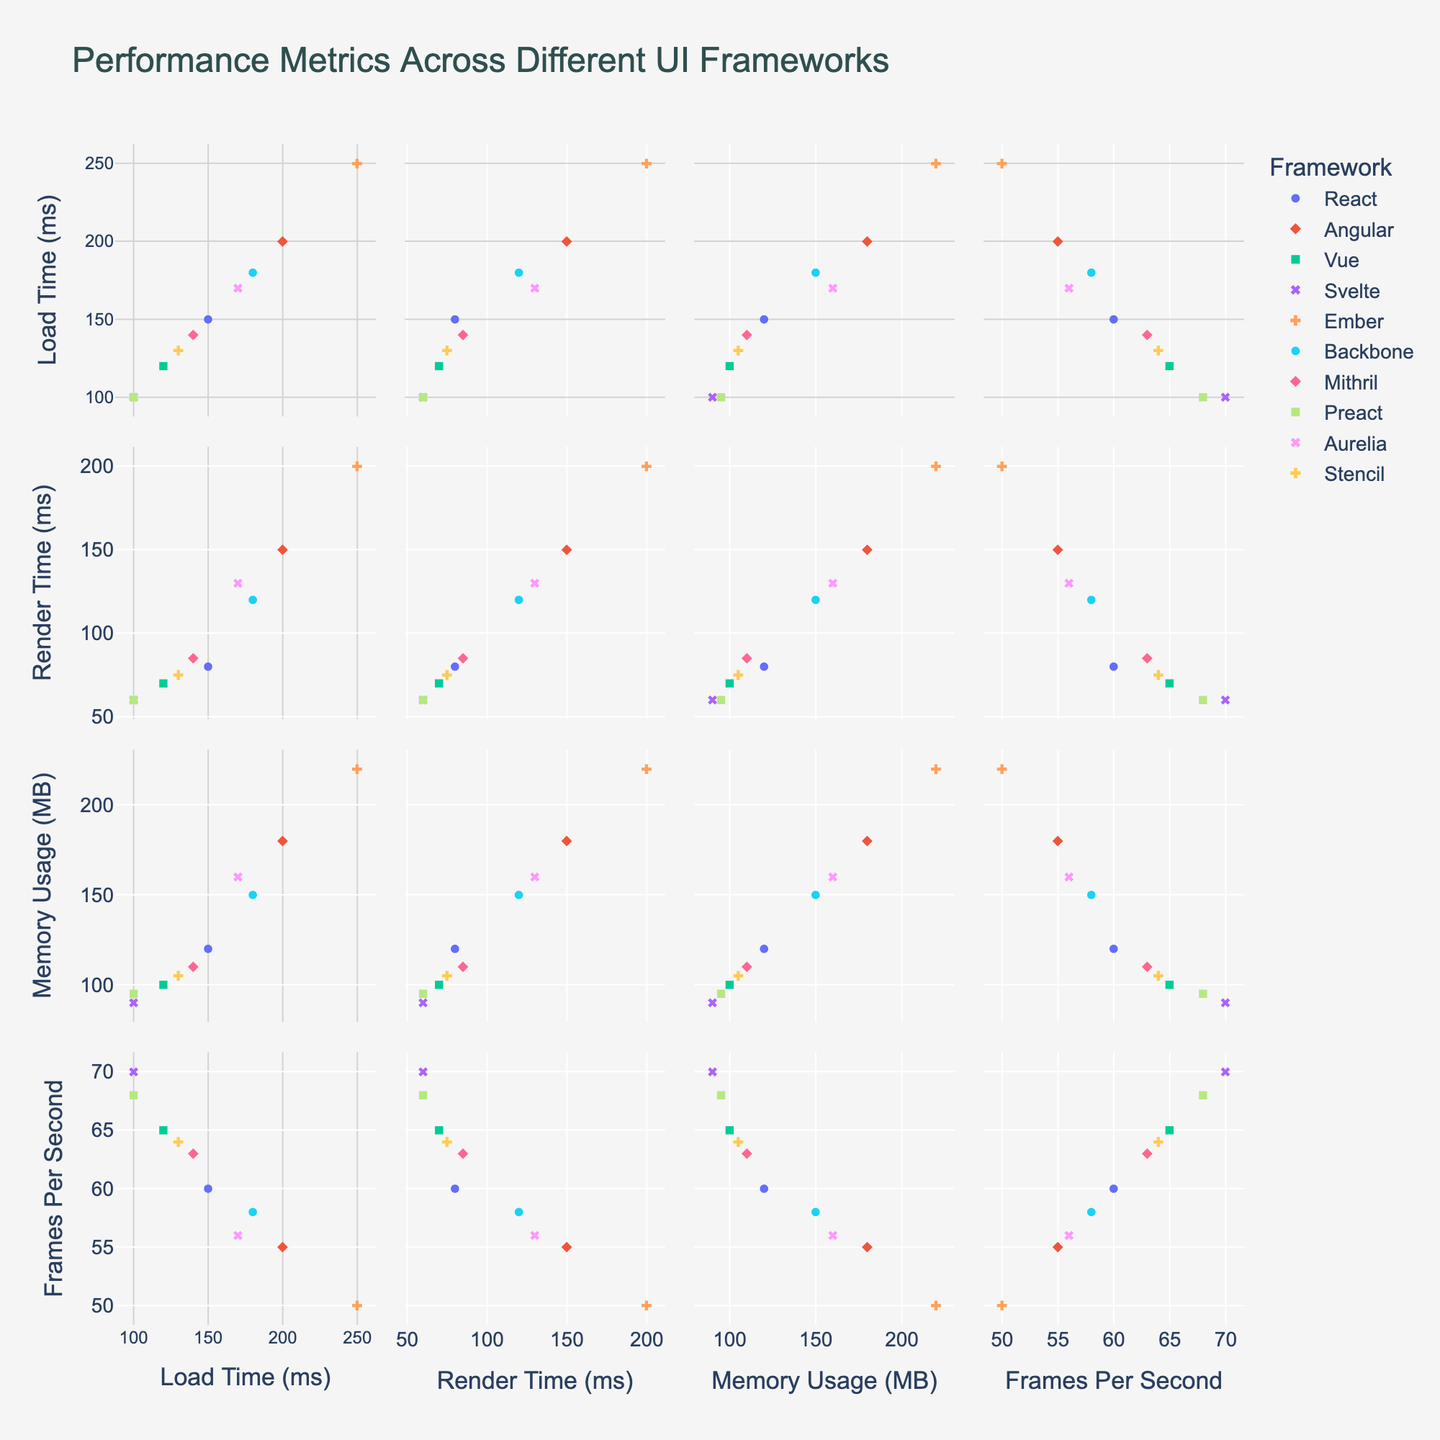What is the title of the plot? Look at the top of the plot where the title is generally displayed.
Answer: Performance Metrics Across Different UI Frameworks How many frameworks are represented in the plot? Each unique framework is represented by a different color and symbol. Count these unique labels in the legend.
Answer: 10 Which framework has the lowest load time and what is its value? Find the data point with the lowest value on the Load Time (ms) axis. The corresponding framework will be labeled.
Answer: Svelte, 100 ms What is the range of memory usage values across the frameworks? Look at the minimum and maximum values on the Memory Usage (MB) axis. The range is the difference between these values.
Answer: 90 MB to 220 MB Comparing React and Angular, which framework has a higher frame rate and by how much? Locate the data points for React and Angular along the Frames Per Second axis, then find the difference between these values.
Answer: React by 5 FPS What is the median load time across all frameworks? Arrange the load times of the frameworks in ascending order and find the middle value in this ordered list.
Answer: 140 ms Is there a noticeable correlation between memory usage and render time across the frameworks? Observing the scatter plots comparing Memory Usage (MB) and Render Time (ms), analyze if there's a trend that shows a direct or inverse relationship.
Answer: Yes, generally positive correlation Which framework performs best in terms of frames per second and what is its value? Identify the data point with the highest value on the Frames Per Second axis. The corresponding framework will be labeled.
Answer: Svelte, 70 FPS Does Preact have both lower load time and render time compared to Ember? Compare the load time and render time values of Preact and Ember by looking at the respective scatter plots.
Answer: Yes, Preact has lower values in both Based on the visual distribution, which performance metric seems to vary the most across different frameworks? Analyze the scatter plots to see which metric displays the widest spread or variation among the frameworks.
Answer: Render Time (ms) 